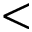<formula> <loc_0><loc_0><loc_500><loc_500><</formula> 